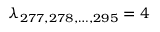<formula> <loc_0><loc_0><loc_500><loc_500>\lambda _ { 2 7 7 , 2 7 8 , \dots , 2 9 5 } = 4</formula> 